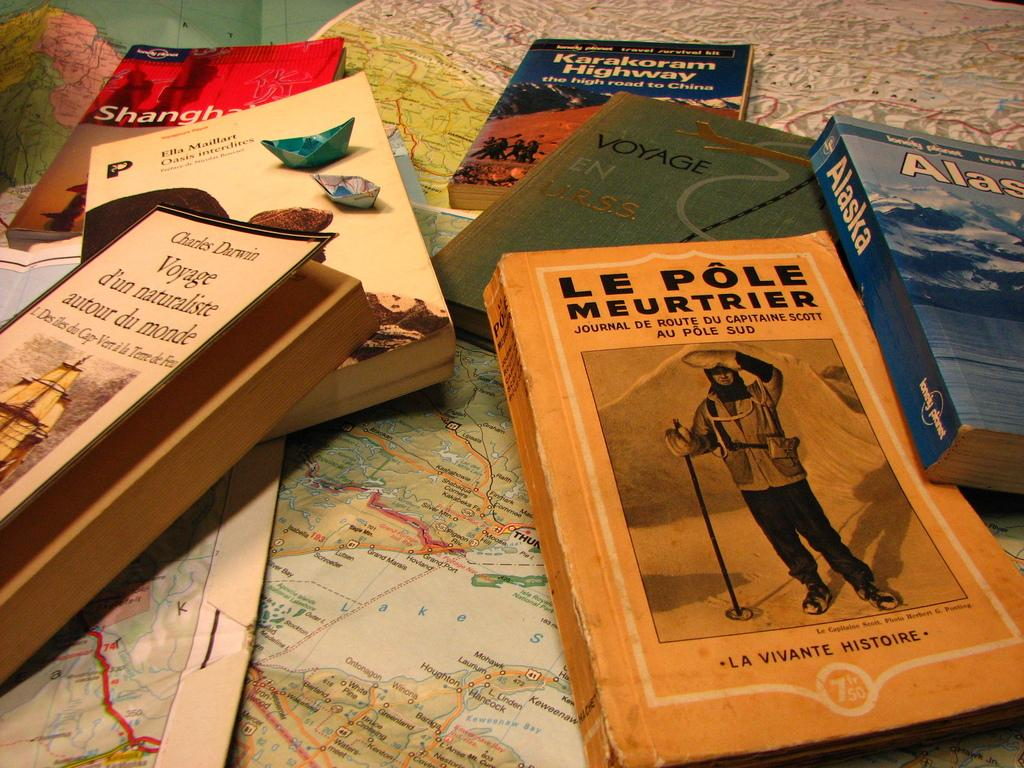What is the main object in the image? There is a table in the image. What is on top of the table? The table is covered with world maps and different types of story books. Where is the pail located in the image? There is no pail present in the image. What type of bag can be seen on the table in the image? There is no bag present on the table in the image. 